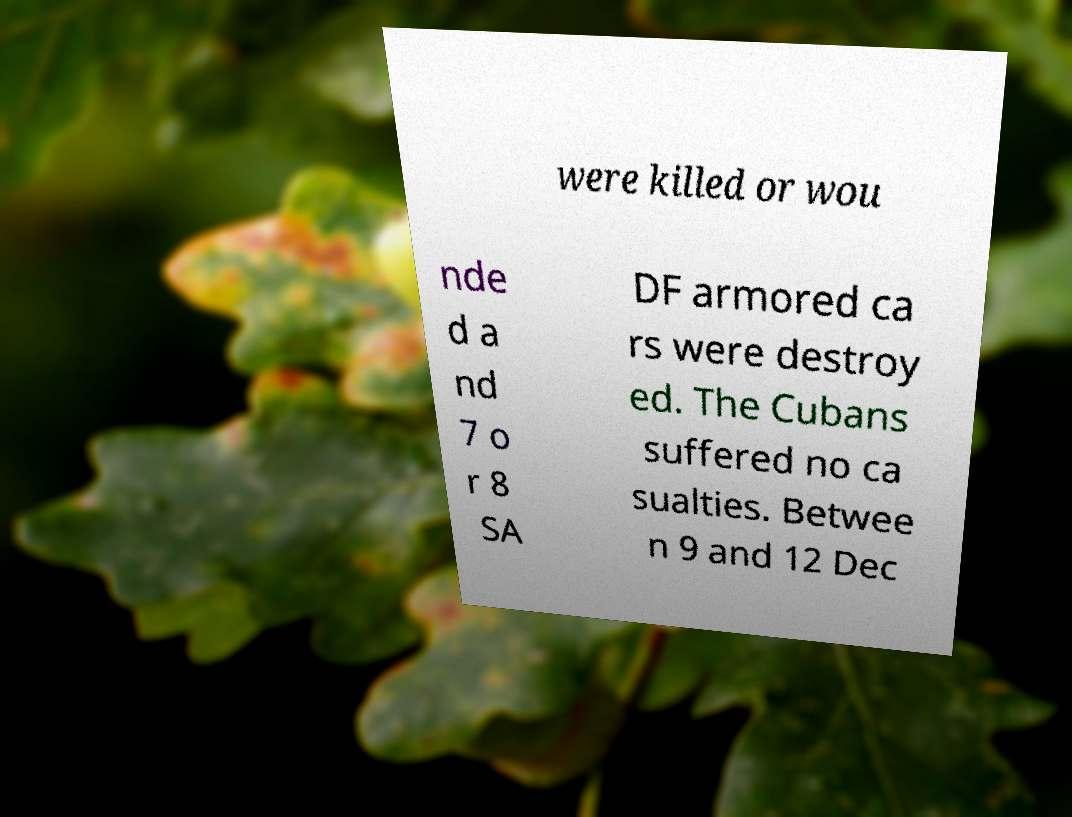Please identify and transcribe the text found in this image. were killed or wou nde d a nd 7 o r 8 SA DF armored ca rs were destroy ed. The Cubans suffered no ca sualties. Betwee n 9 and 12 Dec 